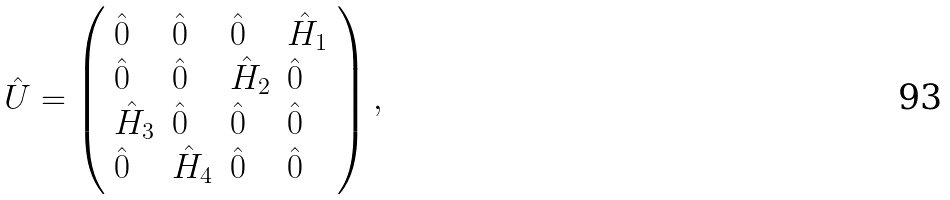<formula> <loc_0><loc_0><loc_500><loc_500>\hat { U } = \left ( \begin{array} { l l l l } \hat { 0 } & \hat { 0 } & \hat { 0 } & \hat { H } _ { 1 } \\ \hat { 0 } & \hat { 0 } & \hat { H } _ { 2 } & \hat { 0 } \\ \hat { H } _ { 3 } & \hat { 0 } & \hat { 0 } & \hat { 0 } \\ \hat { 0 } & \hat { H } _ { 4 } & \hat { 0 } & \hat { 0 } \end{array} \right ) ,</formula> 